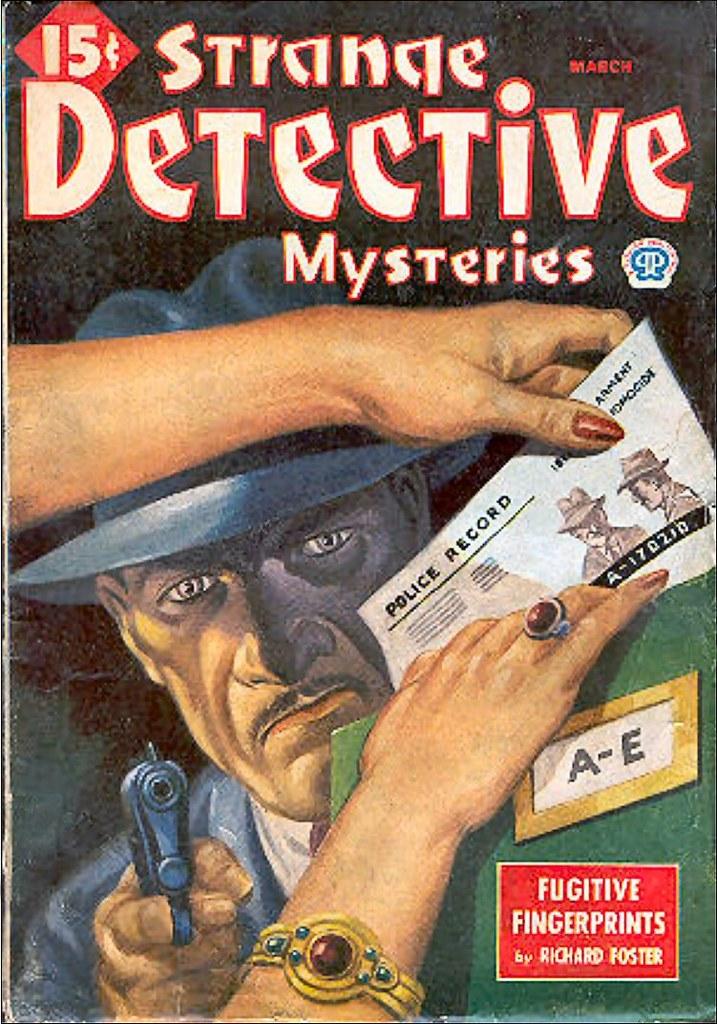Who wrote fugitive fingerprints?
Give a very brief answer. Richard foster. 